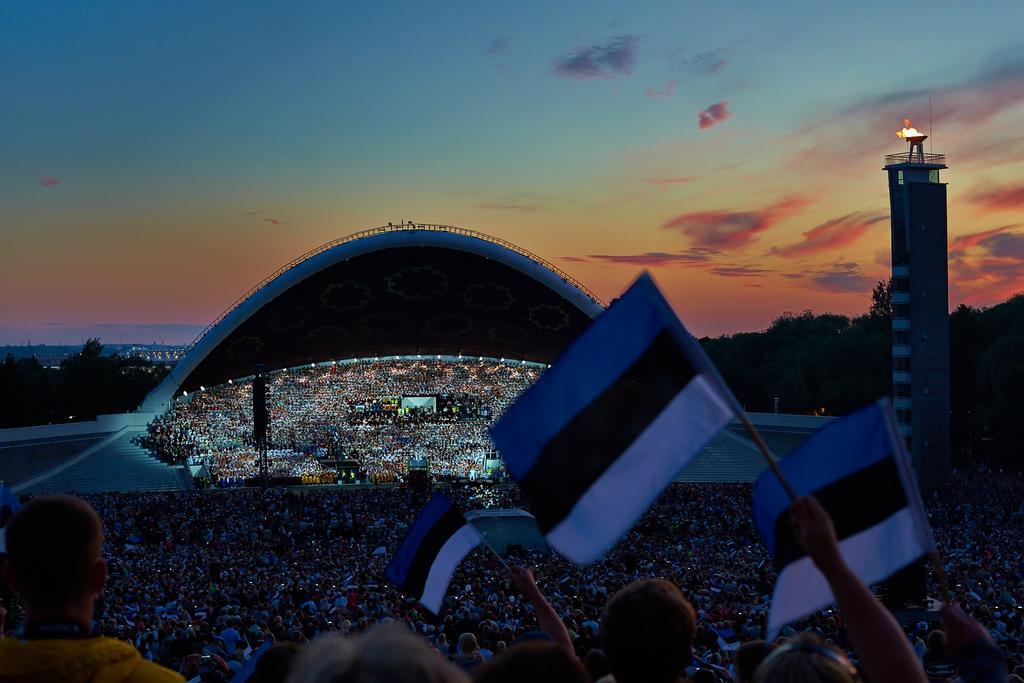Can you describe this image briefly? This is a picture of a Tallinn song festival grounds where there are group of people holding the flags, focus lights, lighting truss, trees, buildings, hills, and in the background there is sky. 